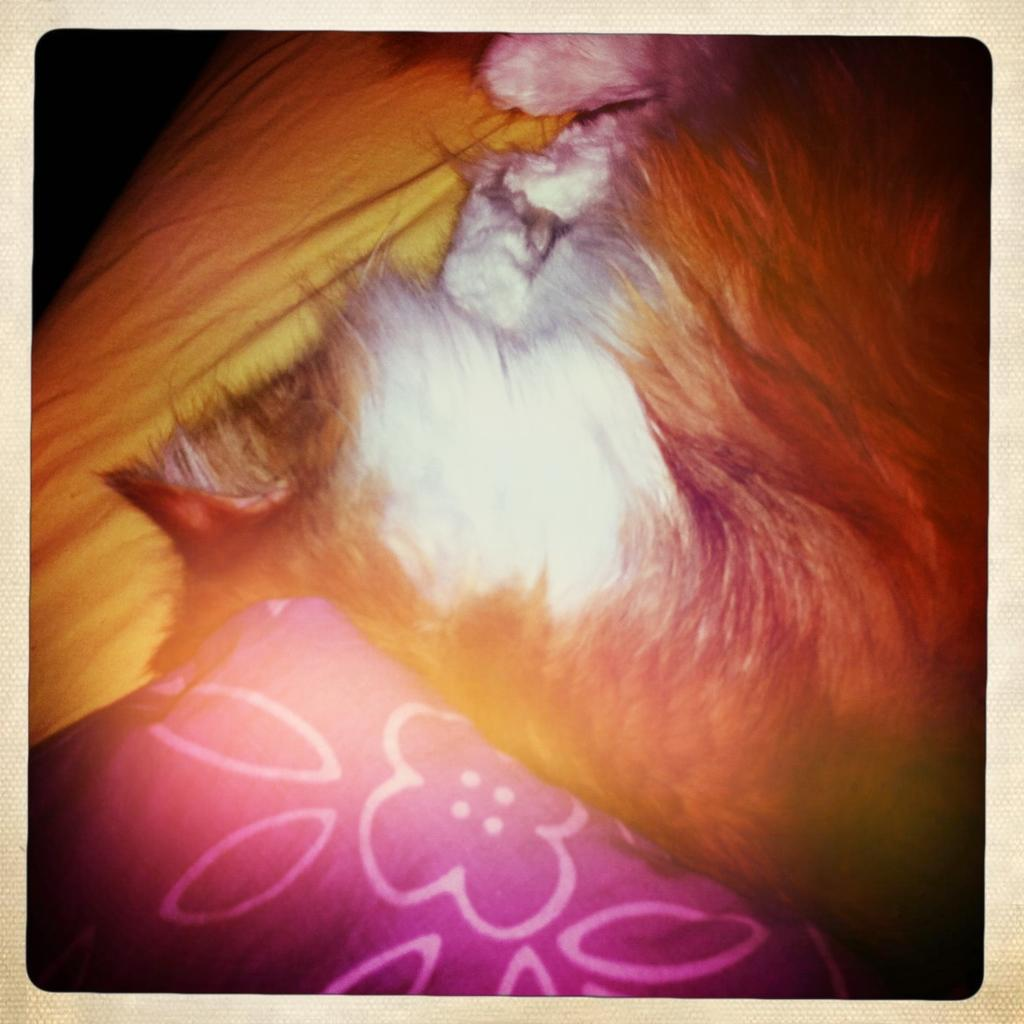What type of object is present in the image? There is an animal in the image. What other item can be seen in the image? There is a pillow in the image. How is the image displayed? The image is in a photo frame. What is the color of the background in the image? The background of the image is dark in color. What is the chance of a tiger appearing in the image? There is no tiger present in the image, so it is not possible to determine the chance of a tiger appearing. Can you tell me where the vase is located in the image? There is no vase present in the image. 